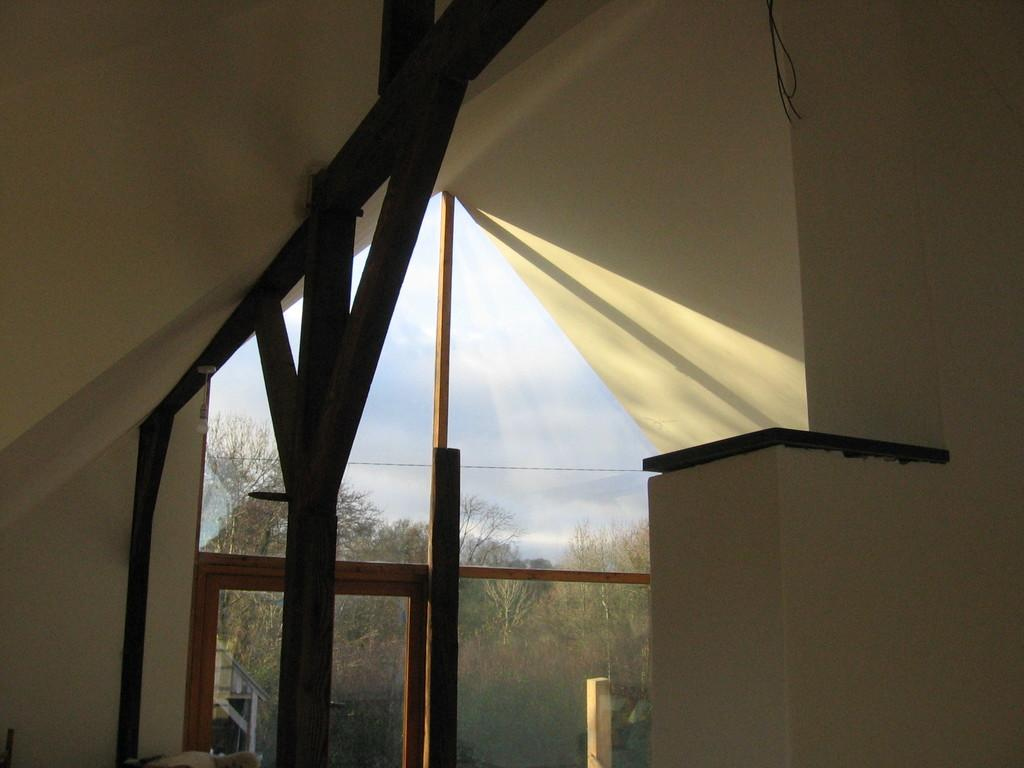What type of location is depicted in the image? The image shows an inside view of a house. What architectural feature can be seen in the middle of the image? There is a pillar in the middle of the image. What can be seen outside the door in the image? There are trees visible outside the door. What type of bone can be seen in the image? There is no bone present in the image. Is there a band playing music in the image? There is no band or music playing in the image. 